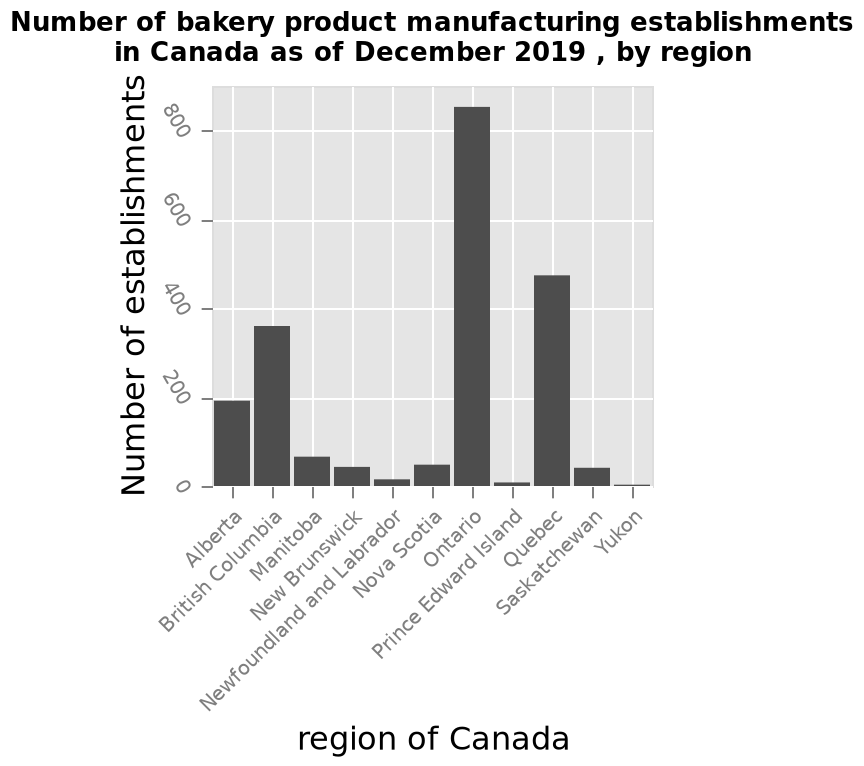<image>
What is the range of values on the y-axis of the bar plot?  The range of values on the y-axis of the bar plot is from 0 to 800. 